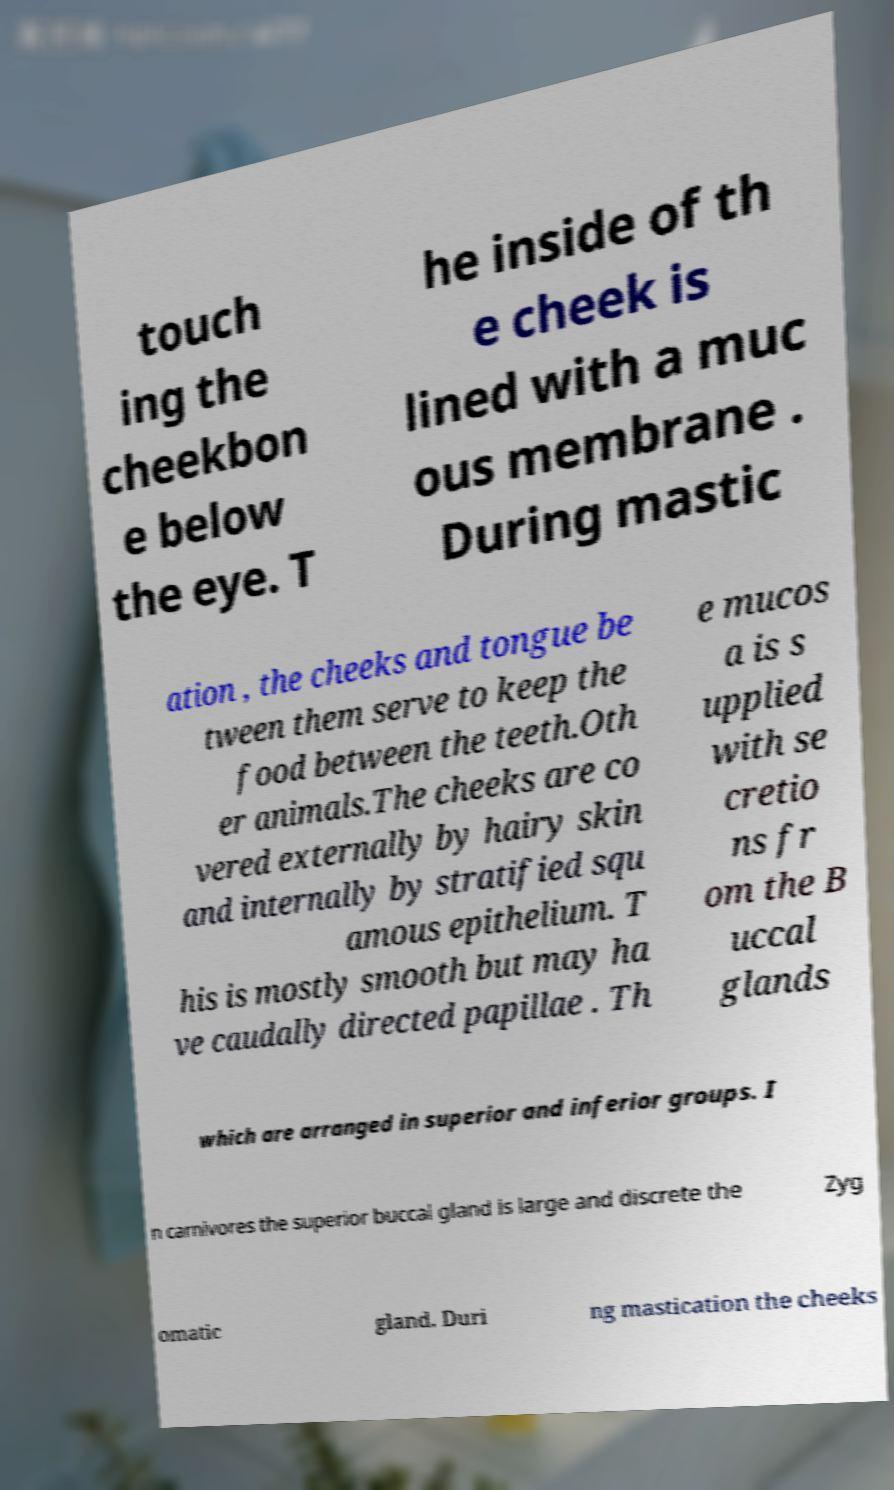Could you extract and type out the text from this image? touch ing the cheekbon e below the eye. T he inside of th e cheek is lined with a muc ous membrane . During mastic ation , the cheeks and tongue be tween them serve to keep the food between the teeth.Oth er animals.The cheeks are co vered externally by hairy skin and internally by stratified squ amous epithelium. T his is mostly smooth but may ha ve caudally directed papillae . Th e mucos a is s upplied with se cretio ns fr om the B uccal glands which are arranged in superior and inferior groups. I n carnivores the superior buccal gland is large and discrete the Zyg omatic gland. Duri ng mastication the cheeks 